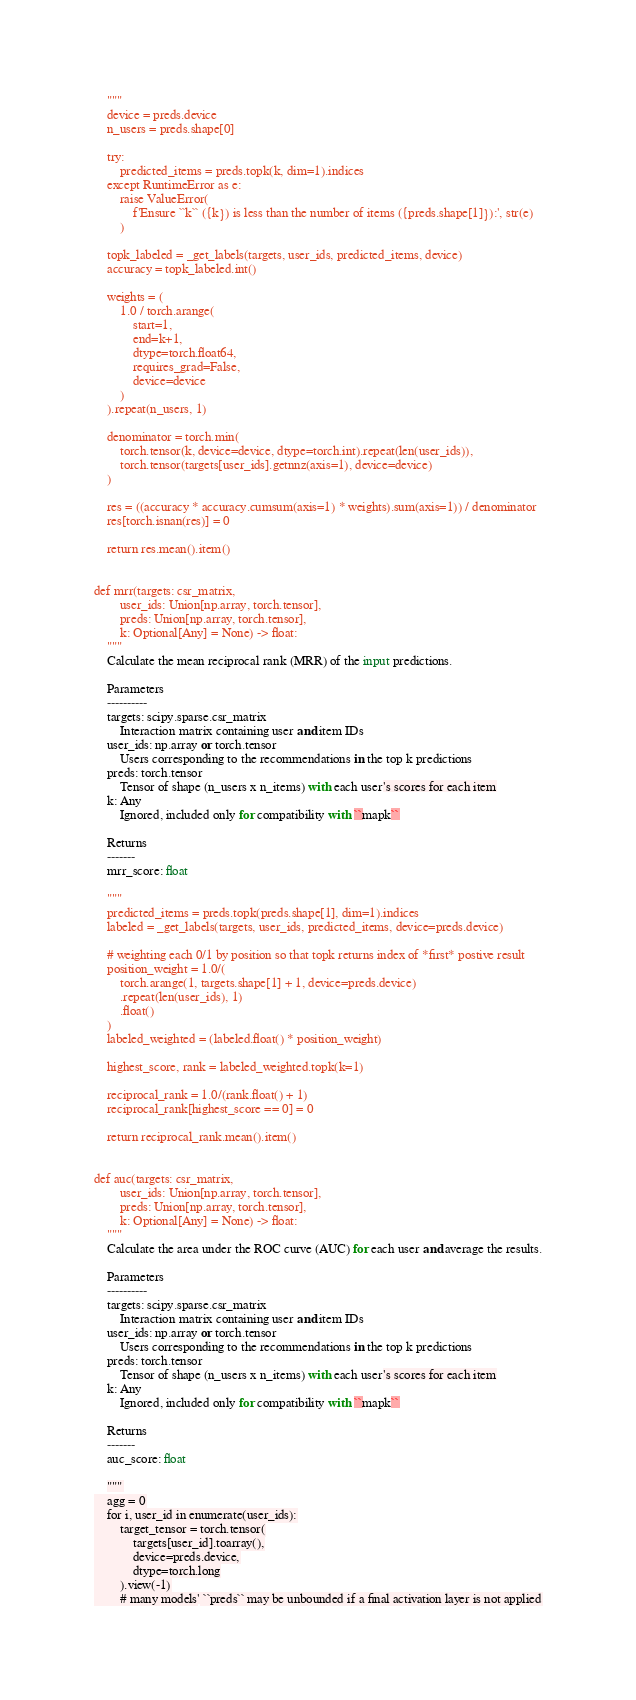<code> <loc_0><loc_0><loc_500><loc_500><_Python_>    """
    device = preds.device
    n_users = preds.shape[0]

    try:
        predicted_items = preds.topk(k, dim=1).indices
    except RuntimeError as e:
        raise ValueError(
            f'Ensure ``k`` ({k}) is less than the number of items ({preds.shape[1]}):', str(e)
        )

    topk_labeled = _get_labels(targets, user_ids, predicted_items, device)
    accuracy = topk_labeled.int()

    weights = (
        1.0 / torch.arange(
            start=1,
            end=k+1,
            dtype=torch.float64,
            requires_grad=False,
            device=device
        )
    ).repeat(n_users, 1)

    denominator = torch.min(
        torch.tensor(k, device=device, dtype=torch.int).repeat(len(user_ids)),
        torch.tensor(targets[user_ids].getnnz(axis=1), device=device)
    )

    res = ((accuracy * accuracy.cumsum(axis=1) * weights).sum(axis=1)) / denominator
    res[torch.isnan(res)] = 0

    return res.mean().item()


def mrr(targets: csr_matrix,
        user_ids: Union[np.array, torch.tensor],
        preds: Union[np.array, torch.tensor],
        k: Optional[Any] = None) -> float:
    """
    Calculate the mean reciprocal rank (MRR) of the input predictions.

    Parameters
    ----------
    targets: scipy.sparse.csr_matrix
        Interaction matrix containing user and item IDs
    user_ids: np.array or torch.tensor
        Users corresponding to the recommendations in the top k predictions
    preds: torch.tensor
        Tensor of shape (n_users x n_items) with each user's scores for each item
    k: Any
        Ignored, included only for compatibility with ``mapk``

    Returns
    -------
    mrr_score: float

    """
    predicted_items = preds.topk(preds.shape[1], dim=1).indices
    labeled = _get_labels(targets, user_ids, predicted_items, device=preds.device)

    # weighting each 0/1 by position so that topk returns index of *first* postive result
    position_weight = 1.0/(
        torch.arange(1, targets.shape[1] + 1, device=preds.device)
        .repeat(len(user_ids), 1)
        .float()
    )
    labeled_weighted = (labeled.float() * position_weight)

    highest_score, rank = labeled_weighted.topk(k=1)

    reciprocal_rank = 1.0/(rank.float() + 1)
    reciprocal_rank[highest_score == 0] = 0

    return reciprocal_rank.mean().item()


def auc(targets: csr_matrix,
        user_ids: Union[np.array, torch.tensor],
        preds: Union[np.array, torch.tensor],
        k: Optional[Any] = None) -> float:
    """
    Calculate the area under the ROC curve (AUC) for each user and average the results.

    Parameters
    ----------
    targets: scipy.sparse.csr_matrix
        Interaction matrix containing user and item IDs
    user_ids: np.array or torch.tensor
        Users corresponding to the recommendations in the top k predictions
    preds: torch.tensor
        Tensor of shape (n_users x n_items) with each user's scores for each item
    k: Any
        Ignored, included only for compatibility with ``mapk``

    Returns
    -------
    auc_score: float

    """
    agg = 0
    for i, user_id in enumerate(user_ids):
        target_tensor = torch.tensor(
            targets[user_id].toarray(),
            device=preds.device,
            dtype=torch.long
        ).view(-1)
        # many models' ``preds`` may be unbounded if a final activation layer is not applied</code> 